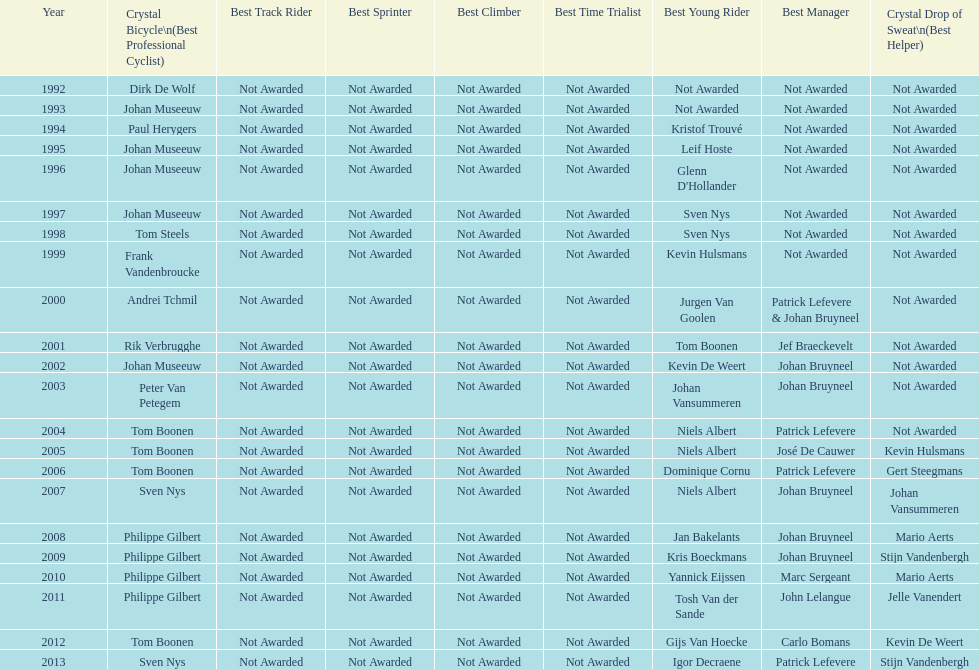What is the total number of times johan bryneel's name appears on all of these lists? 6. 